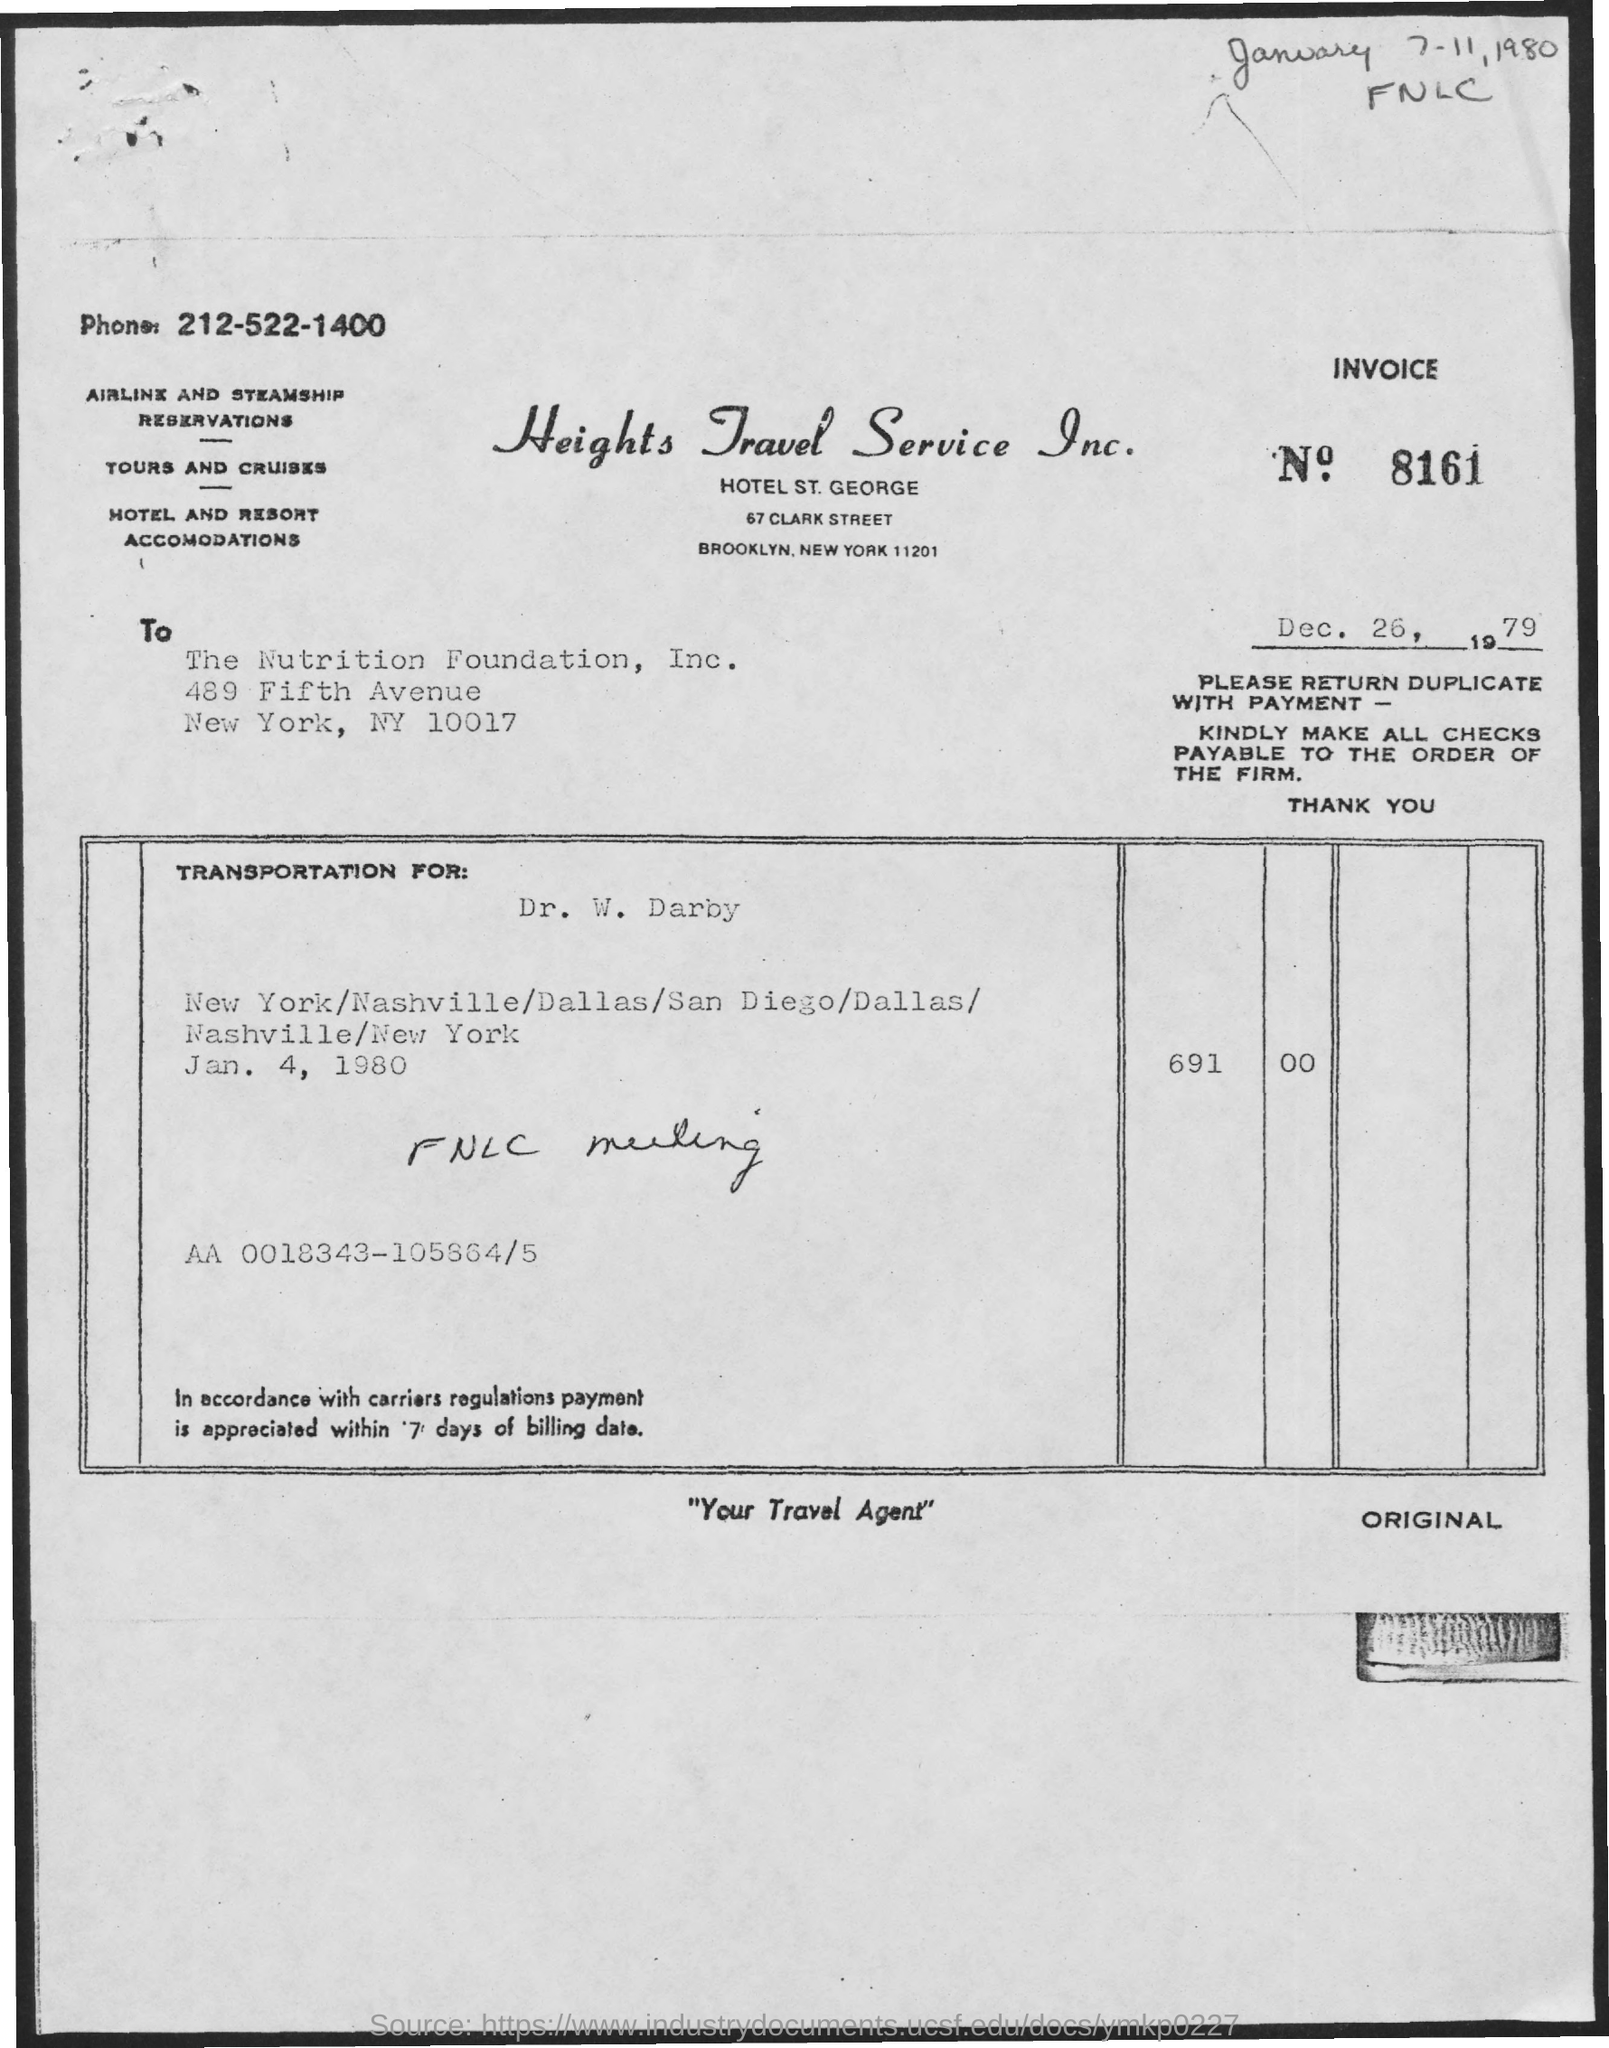Highlight a few significant elements in this photo. The transportation date mentioned is January 4, 1980. The phone number is 212-522-1400. The nutrition foundation, Inc. is located in New York City. The person whose name is mentioned in the transportation is Dr. W. Darby. The Nutrition Foundation, Inc. is mentioned in the text. 